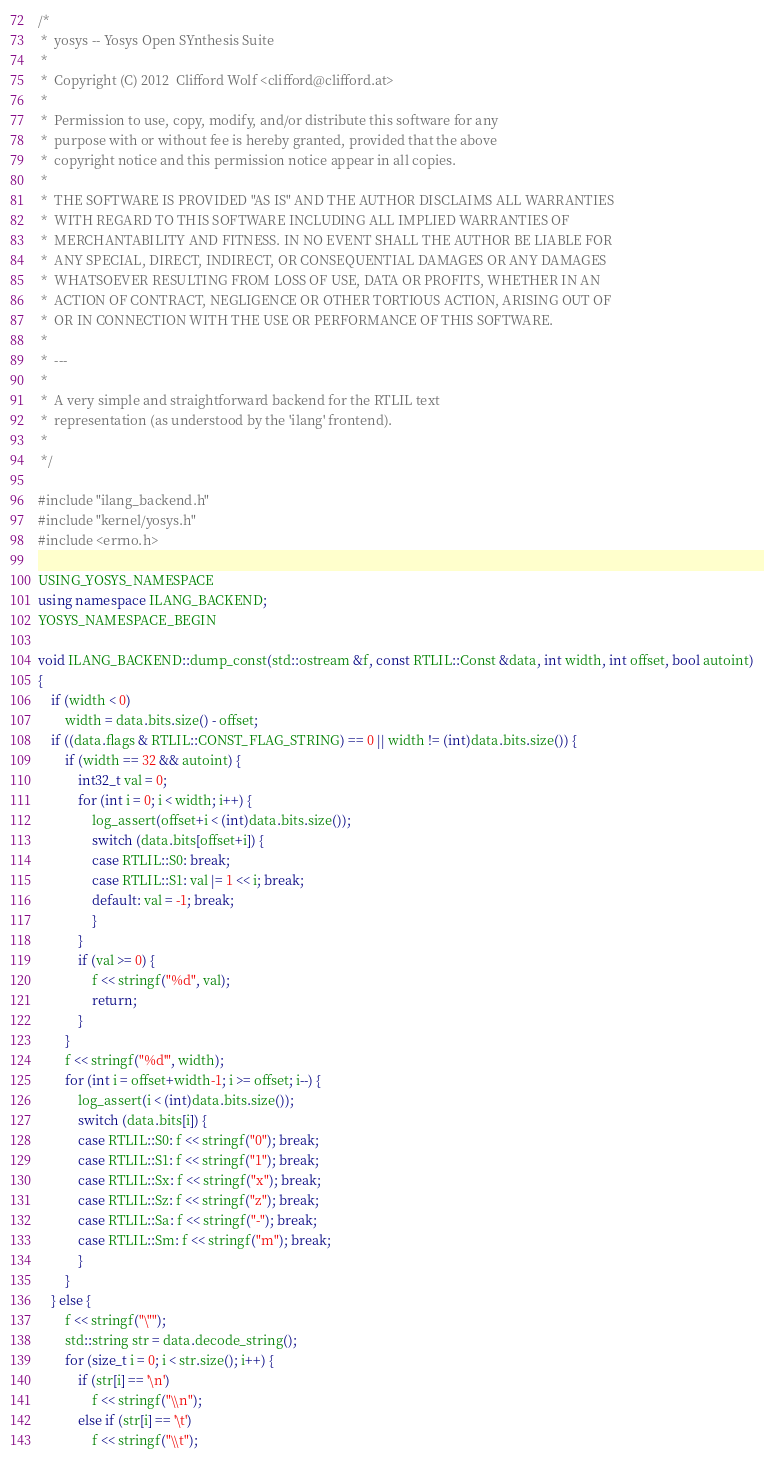<code> <loc_0><loc_0><loc_500><loc_500><_C++_>/*
 *  yosys -- Yosys Open SYnthesis Suite
 *
 *  Copyright (C) 2012  Clifford Wolf <clifford@clifford.at>
 *
 *  Permission to use, copy, modify, and/or distribute this software for any
 *  purpose with or without fee is hereby granted, provided that the above
 *  copyright notice and this permission notice appear in all copies.
 *
 *  THE SOFTWARE IS PROVIDED "AS IS" AND THE AUTHOR DISCLAIMS ALL WARRANTIES
 *  WITH REGARD TO THIS SOFTWARE INCLUDING ALL IMPLIED WARRANTIES OF
 *  MERCHANTABILITY AND FITNESS. IN NO EVENT SHALL THE AUTHOR BE LIABLE FOR
 *  ANY SPECIAL, DIRECT, INDIRECT, OR CONSEQUENTIAL DAMAGES OR ANY DAMAGES
 *  WHATSOEVER RESULTING FROM LOSS OF USE, DATA OR PROFITS, WHETHER IN AN
 *  ACTION OF CONTRACT, NEGLIGENCE OR OTHER TORTIOUS ACTION, ARISING OUT OF
 *  OR IN CONNECTION WITH THE USE OR PERFORMANCE OF THIS SOFTWARE.
 *
 *  ---
 *
 *  A very simple and straightforward backend for the RTLIL text
 *  representation (as understood by the 'ilang' frontend).
 *
 */

#include "ilang_backend.h"
#include "kernel/yosys.h"
#include <errno.h>

USING_YOSYS_NAMESPACE
using namespace ILANG_BACKEND;
YOSYS_NAMESPACE_BEGIN

void ILANG_BACKEND::dump_const(std::ostream &f, const RTLIL::Const &data, int width, int offset, bool autoint)
{
	if (width < 0)
		width = data.bits.size() - offset;
	if ((data.flags & RTLIL::CONST_FLAG_STRING) == 0 || width != (int)data.bits.size()) {
		if (width == 32 && autoint) {
			int32_t val = 0;
			for (int i = 0; i < width; i++) {
				log_assert(offset+i < (int)data.bits.size());
				switch (data.bits[offset+i]) {
				case RTLIL::S0: break;
				case RTLIL::S1: val |= 1 << i; break;
				default: val = -1; break;
				}
			}
			if (val >= 0) {
				f << stringf("%d", val);
				return;
			}
		}
		f << stringf("%d'", width);
		for (int i = offset+width-1; i >= offset; i--) {
			log_assert(i < (int)data.bits.size());
			switch (data.bits[i]) {
			case RTLIL::S0: f << stringf("0"); break;
			case RTLIL::S1: f << stringf("1"); break;
			case RTLIL::Sx: f << stringf("x"); break;
			case RTLIL::Sz: f << stringf("z"); break;
			case RTLIL::Sa: f << stringf("-"); break;
			case RTLIL::Sm: f << stringf("m"); break;
			}
		}
	} else {
		f << stringf("\"");
		std::string str = data.decode_string();
		for (size_t i = 0; i < str.size(); i++) {
			if (str[i] == '\n')
				f << stringf("\\n");
			else if (str[i] == '\t')
				f << stringf("\\t");</code> 